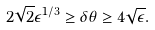<formula> <loc_0><loc_0><loc_500><loc_500>2 \sqrt { 2 } \epsilon ^ { 1 / 3 } \geq \delta \theta \geq 4 \sqrt { \epsilon } .</formula> 